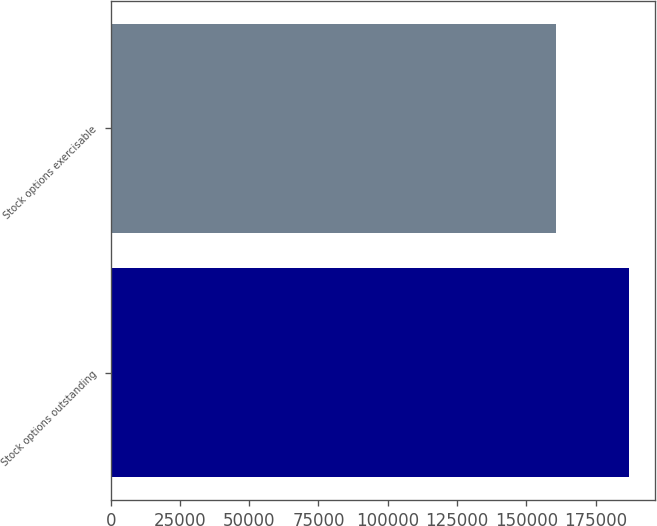<chart> <loc_0><loc_0><loc_500><loc_500><bar_chart><fcel>Stock options outstanding<fcel>Stock options exercisable<nl><fcel>186956<fcel>160606<nl></chart> 